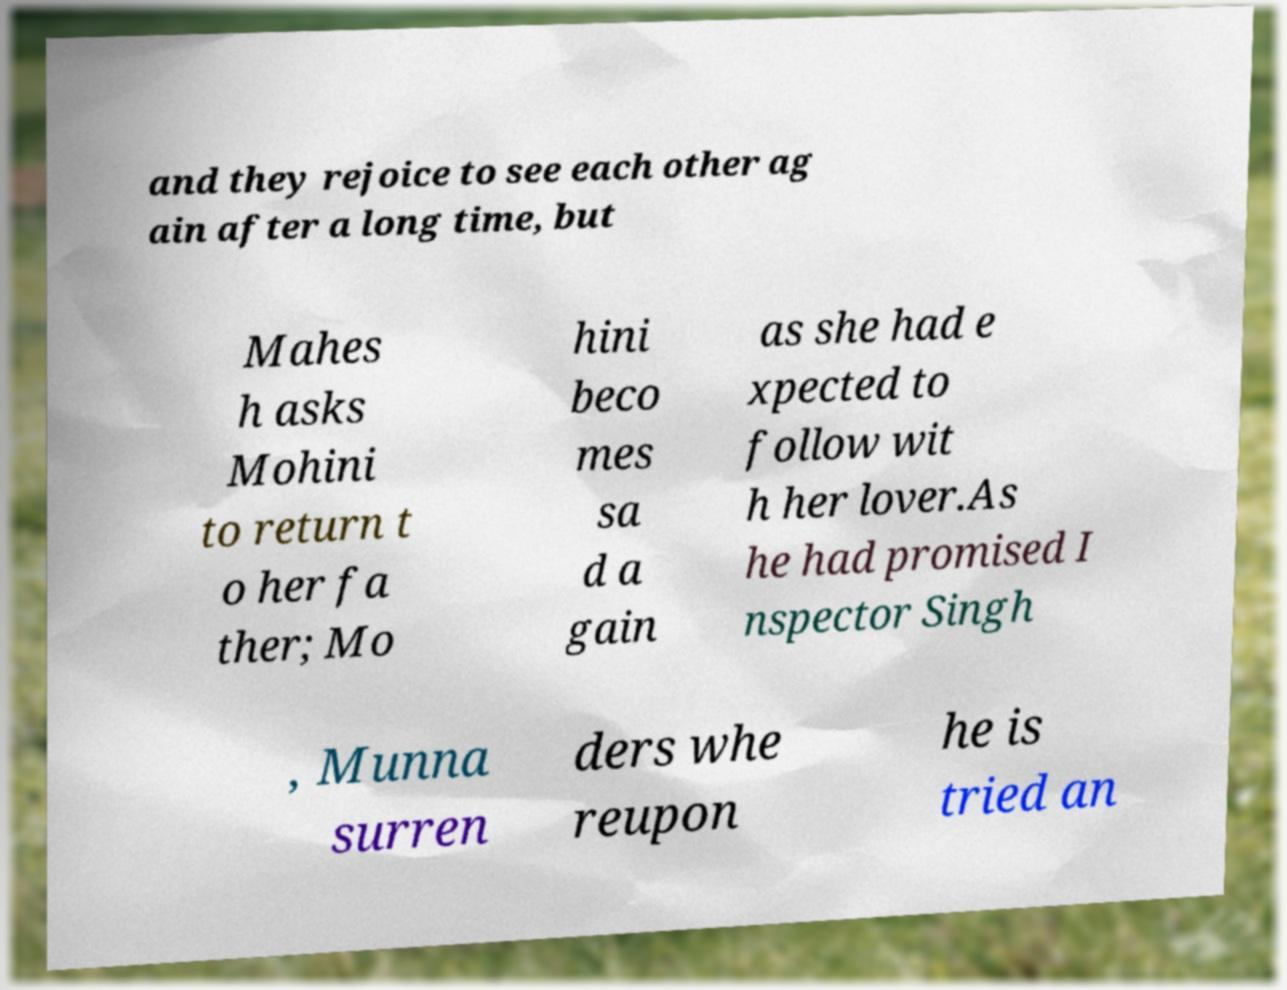Could you assist in decoding the text presented in this image and type it out clearly? and they rejoice to see each other ag ain after a long time, but Mahes h asks Mohini to return t o her fa ther; Mo hini beco mes sa d a gain as she had e xpected to follow wit h her lover.As he had promised I nspector Singh , Munna surren ders whe reupon he is tried an 